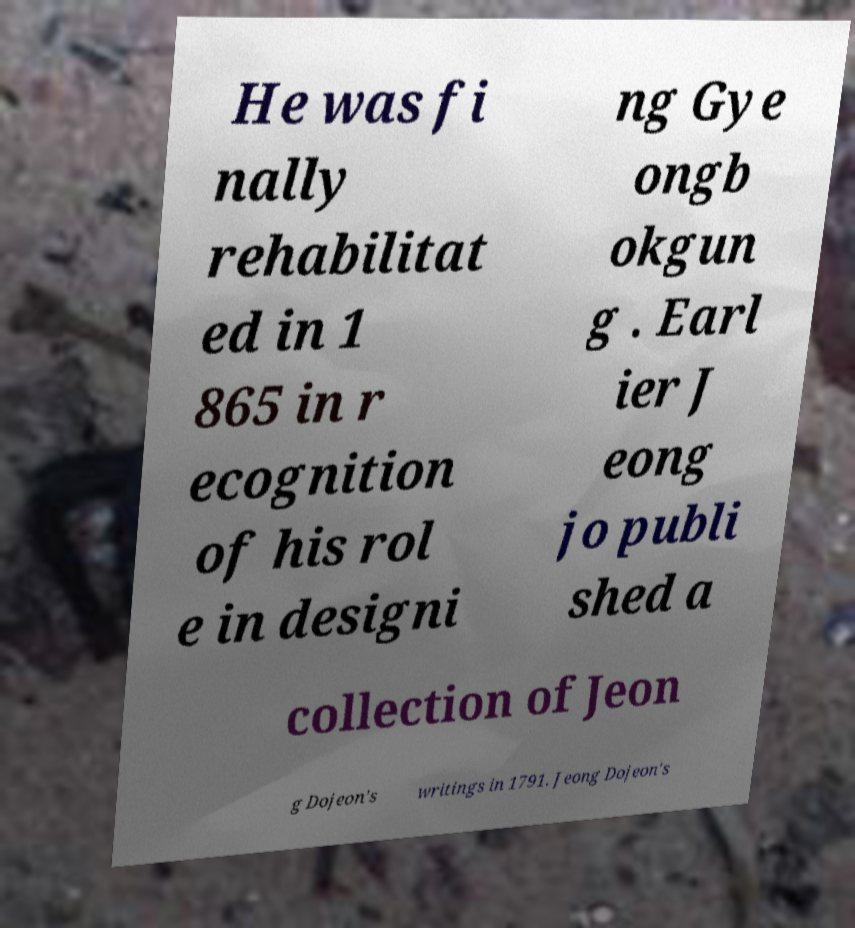I need the written content from this picture converted into text. Can you do that? He was fi nally rehabilitat ed in 1 865 in r ecognition of his rol e in designi ng Gye ongb okgun g . Earl ier J eong jo publi shed a collection of Jeon g Dojeon's writings in 1791. Jeong Dojeon's 